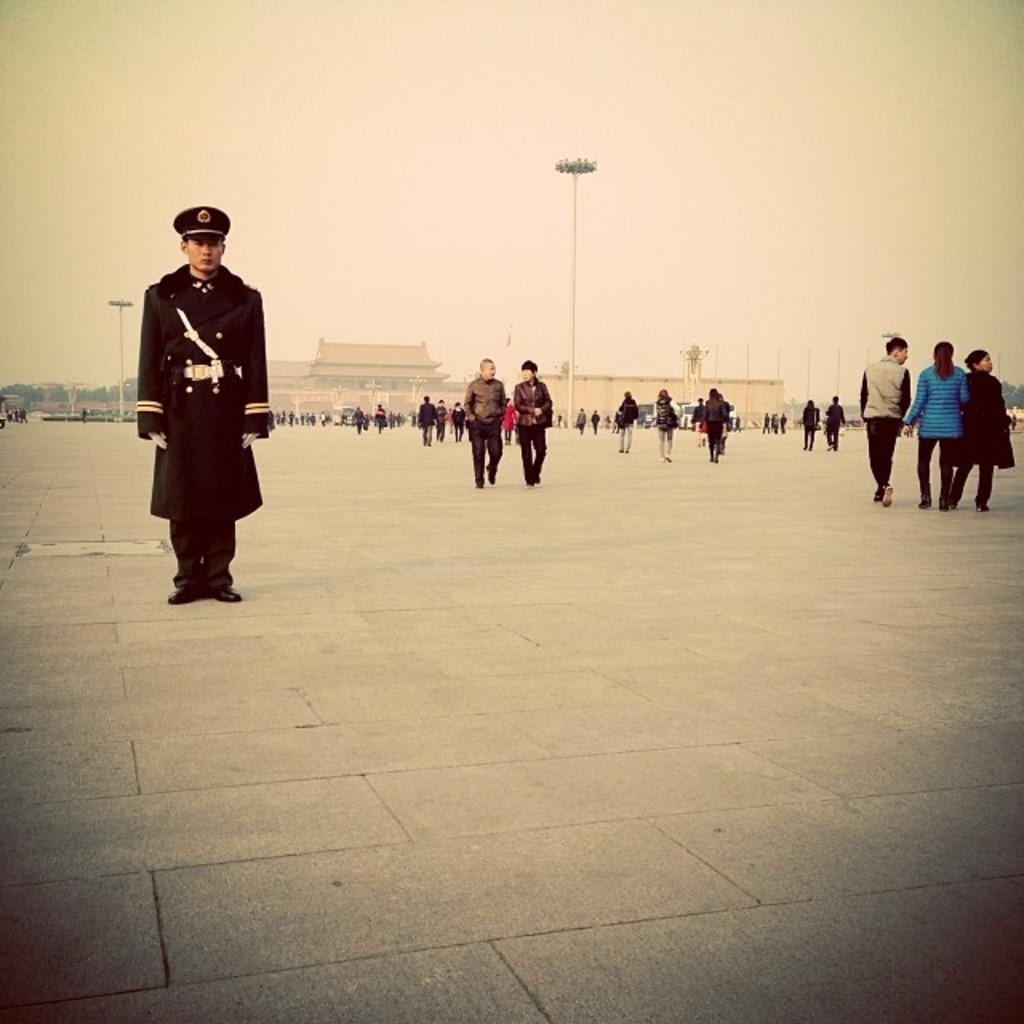What is located on the left side of the image? There is a man on the left side of the image. What is the man wearing in the image? The man is wearing a black dress and a cap. What can be seen on the right side of the image? There are people walking on the right side of the image. What is visible on the ground in the image? The floor is visible in the image. What is visible at the top of the image? The sky is visible at the top of the image. What is the purpose of the creator in the image? There is no creator present in the image; it is a photograph of a man and people walking. Can you tell me how many times the people on the right side of the image are laughing? There is no indication of laughter in the image; people are simply walking. 